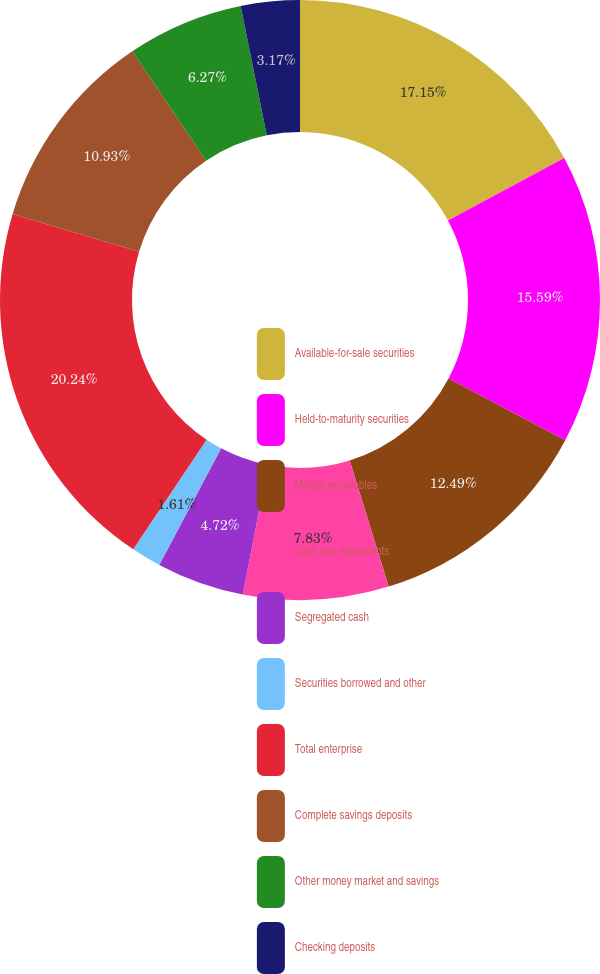<chart> <loc_0><loc_0><loc_500><loc_500><pie_chart><fcel>Available-for-sale securities<fcel>Held-to-maturity securities<fcel>Margin receivables<fcel>Cash and equivalents<fcel>Segregated cash<fcel>Securities borrowed and other<fcel>Total enterprise<fcel>Complete savings deposits<fcel>Other money market and savings<fcel>Checking deposits<nl><fcel>17.15%<fcel>15.59%<fcel>12.49%<fcel>7.83%<fcel>4.72%<fcel>1.61%<fcel>20.25%<fcel>10.93%<fcel>6.27%<fcel>3.17%<nl></chart> 